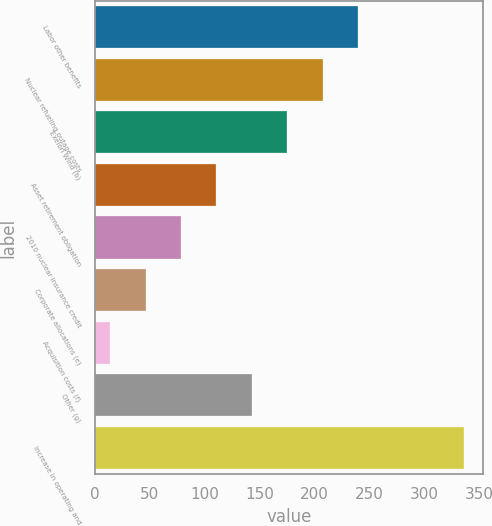Convert chart. <chart><loc_0><loc_0><loc_500><loc_500><bar_chart><fcel>Labor other benefits<fcel>Nuclear refueling outage costs<fcel>Exelon Wind (b)<fcel>Asset retirement obligation<fcel>2010 nuclear insurance credit<fcel>Corporate allocations (e)<fcel>Acquisition costs (f)<fcel>Other (g)<fcel>Increase in operating and<nl><fcel>239.4<fcel>207.2<fcel>175<fcel>110.6<fcel>78.4<fcel>46.2<fcel>14<fcel>142.8<fcel>336<nl></chart> 